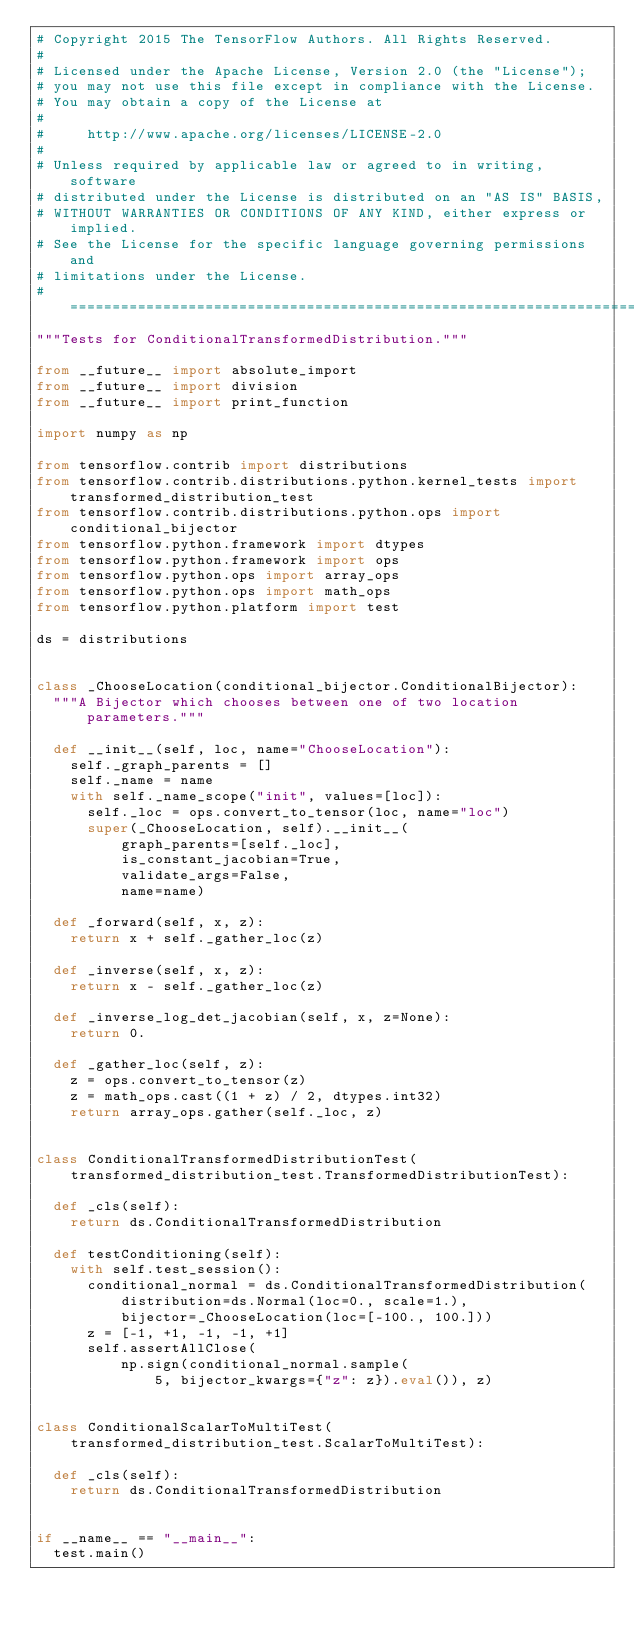Convert code to text. <code><loc_0><loc_0><loc_500><loc_500><_Python_># Copyright 2015 The TensorFlow Authors. All Rights Reserved.
#
# Licensed under the Apache License, Version 2.0 (the "License");
# you may not use this file except in compliance with the License.
# You may obtain a copy of the License at
#
#     http://www.apache.org/licenses/LICENSE-2.0
#
# Unless required by applicable law or agreed to in writing, software
# distributed under the License is distributed on an "AS IS" BASIS,
# WITHOUT WARRANTIES OR CONDITIONS OF ANY KIND, either express or implied.
# See the License for the specific language governing permissions and
# limitations under the License.
# ==============================================================================
"""Tests for ConditionalTransformedDistribution."""

from __future__ import absolute_import
from __future__ import division
from __future__ import print_function

import numpy as np

from tensorflow.contrib import distributions
from tensorflow.contrib.distributions.python.kernel_tests import transformed_distribution_test
from tensorflow.contrib.distributions.python.ops import conditional_bijector
from tensorflow.python.framework import dtypes
from tensorflow.python.framework import ops
from tensorflow.python.ops import array_ops
from tensorflow.python.ops import math_ops
from tensorflow.python.platform import test

ds = distributions


class _ChooseLocation(conditional_bijector.ConditionalBijector):
  """A Bijector which chooses between one of two location parameters."""

  def __init__(self, loc, name="ChooseLocation"):
    self._graph_parents = []
    self._name = name
    with self._name_scope("init", values=[loc]):
      self._loc = ops.convert_to_tensor(loc, name="loc")
      super(_ChooseLocation, self).__init__(
          graph_parents=[self._loc],
          is_constant_jacobian=True,
          validate_args=False,
          name=name)

  def _forward(self, x, z):
    return x + self._gather_loc(z)

  def _inverse(self, x, z):
    return x - self._gather_loc(z)

  def _inverse_log_det_jacobian(self, x, z=None):
    return 0.

  def _gather_loc(self, z):
    z = ops.convert_to_tensor(z)
    z = math_ops.cast((1 + z) / 2, dtypes.int32)
    return array_ops.gather(self._loc, z)


class ConditionalTransformedDistributionTest(
    transformed_distribution_test.TransformedDistributionTest):

  def _cls(self):
    return ds.ConditionalTransformedDistribution

  def testConditioning(self):
    with self.test_session():
      conditional_normal = ds.ConditionalTransformedDistribution(
          distribution=ds.Normal(loc=0., scale=1.),
          bijector=_ChooseLocation(loc=[-100., 100.]))
      z = [-1, +1, -1, -1, +1]
      self.assertAllClose(
          np.sign(conditional_normal.sample(
              5, bijector_kwargs={"z": z}).eval()), z)


class ConditionalScalarToMultiTest(
    transformed_distribution_test.ScalarToMultiTest):

  def _cls(self):
    return ds.ConditionalTransformedDistribution


if __name__ == "__main__":
  test.main()
</code> 